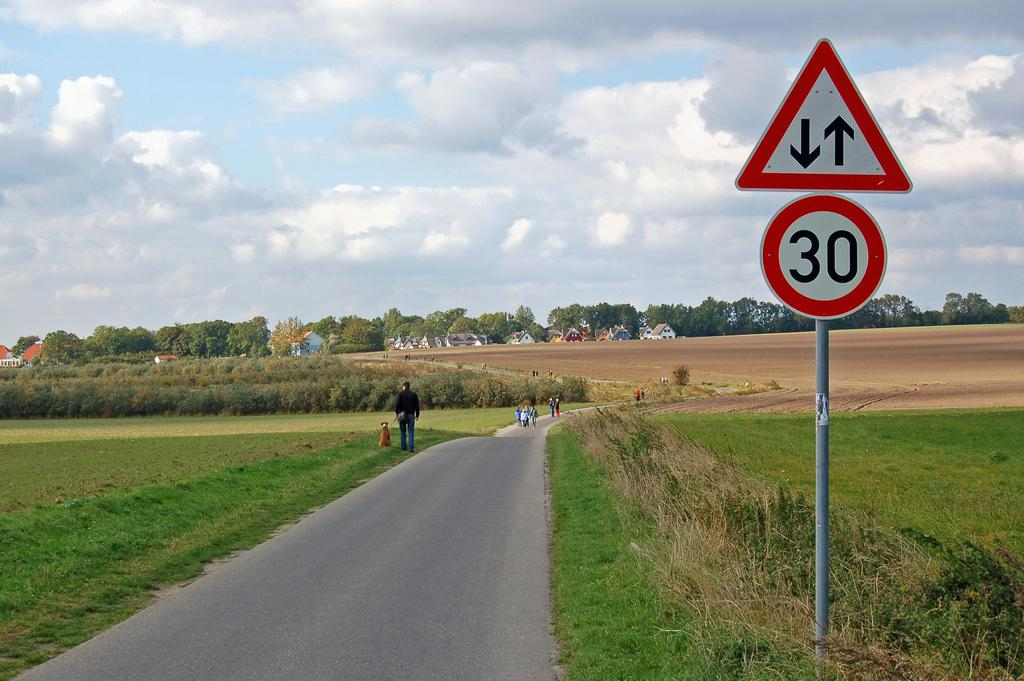<image>
Present a compact description of the photo's key features. A sign to let car know that the speed limit is 30 and some people are walking at the back. 